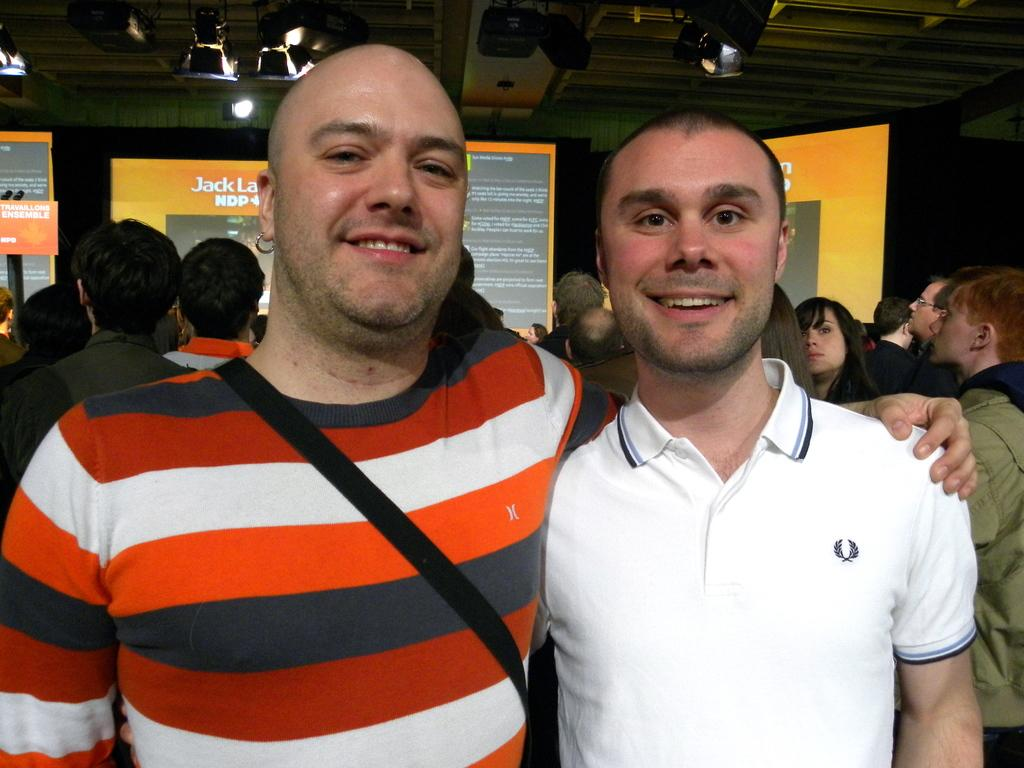<image>
Render a clear and concise summary of the photo. Two young men one in a striped shirt and the other in a white polo stand in front of many people and a screen with Jack on it, 